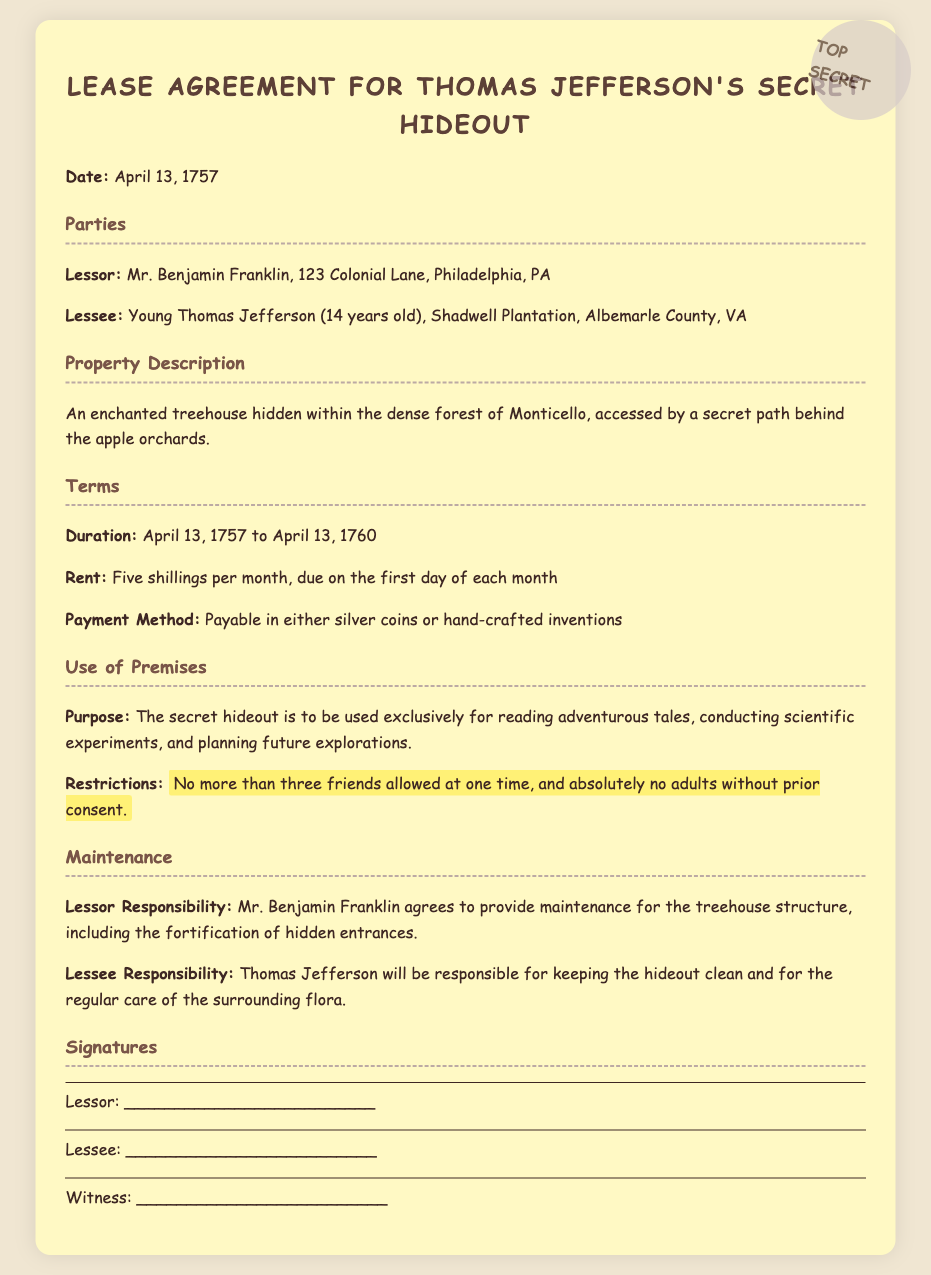What is the date of the lease agreement? The date of the lease agreement is specified at the beginning of the document.
Answer: April 13, 1757 Who is the lessor in the agreement? The lessor is the person who is renting out the property, mentioned in the parties section.
Answer: Mr. Benjamin Franklin What is the duration of the lease? The duration describes the time period for which the lease is valid, indicated in the terms section.
Answer: April 13, 1757 to April 13, 1760 How much is the rent per month? The rent amount is detailed in the terms section of the document.
Answer: Five shillings What can the hideout be used for? The purpose is stated clearly in the use of premises section of the lease.
Answer: Reading adventurous tales, conducting scientific experiments, and planning future explorations What is the maximum number of friends allowed? This restriction is mentioned in the use of premises section and specifies how many friends can be at the hideout.
Answer: Three friends Who is responsible for maintenance of the treehouse? The maintenance responsibilities outline who is in charge of the upkeep in the agreement.
Answer: Mr. Benjamin Franklin What payment methods are accepted for rent? The payment method details the allowed forms of payment as specified in the terms section.
Answer: Silver coins or hand-crafted inventions What is one restriction mentioned in the lease? The restrictions section highlights specific rules regarding the use of the hideout.
Answer: No more than three friends allowed at one time 